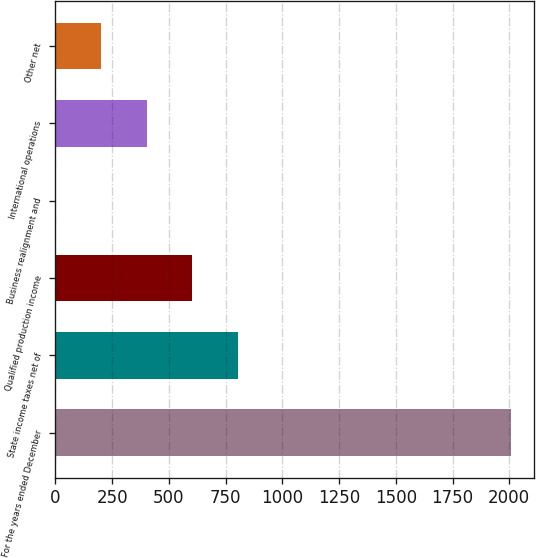<chart> <loc_0><loc_0><loc_500><loc_500><bar_chart><fcel>For the years ended December<fcel>State income taxes net of<fcel>Qualified production income<fcel>Business realignment and<fcel>International operations<fcel>Other net<nl><fcel>2008<fcel>803.62<fcel>602.89<fcel>0.7<fcel>402.16<fcel>201.43<nl></chart> 